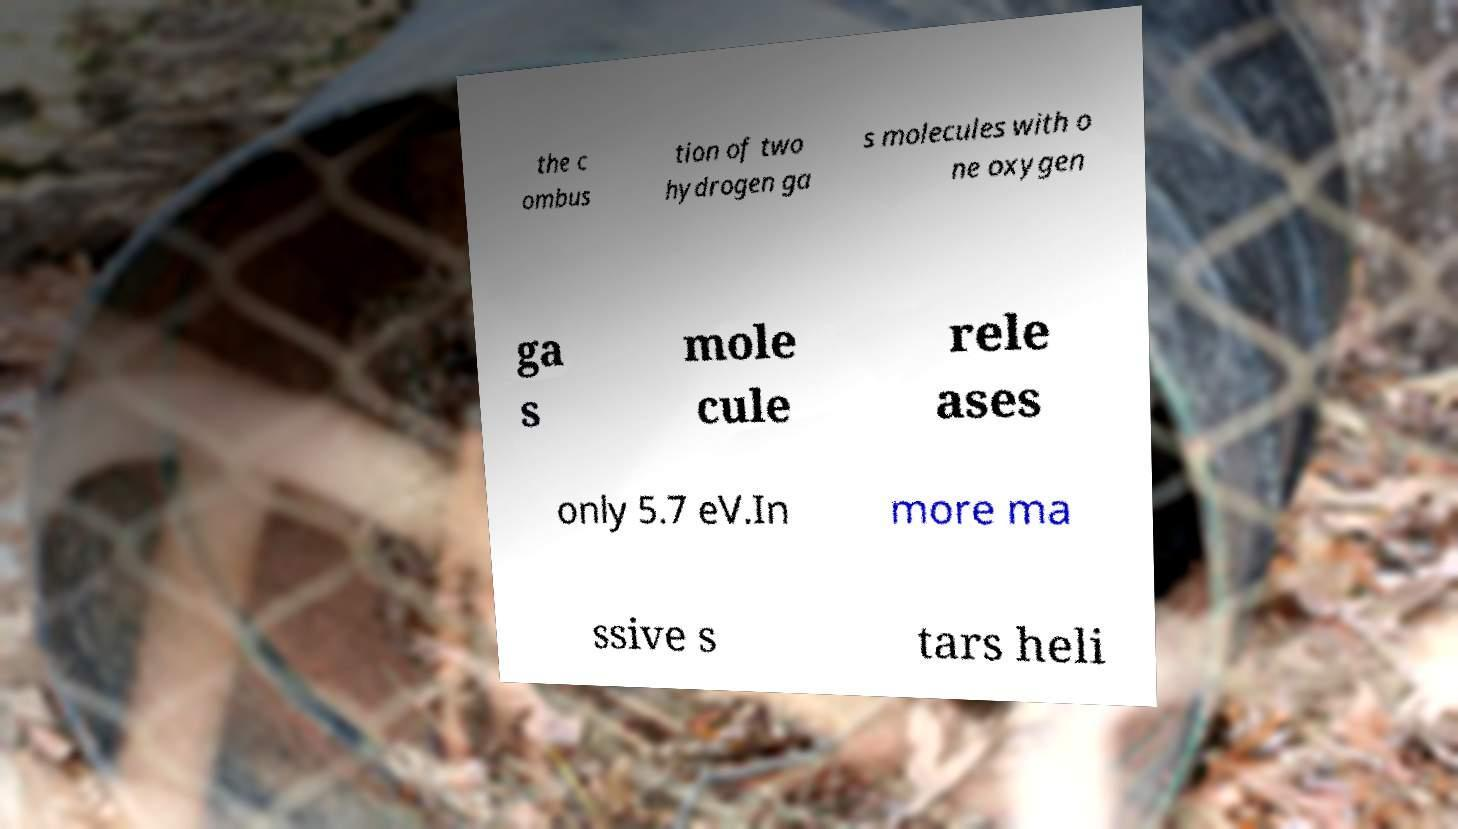Could you assist in decoding the text presented in this image and type it out clearly? the c ombus tion of two hydrogen ga s molecules with o ne oxygen ga s mole cule rele ases only 5.7 eV.In more ma ssive s tars heli 